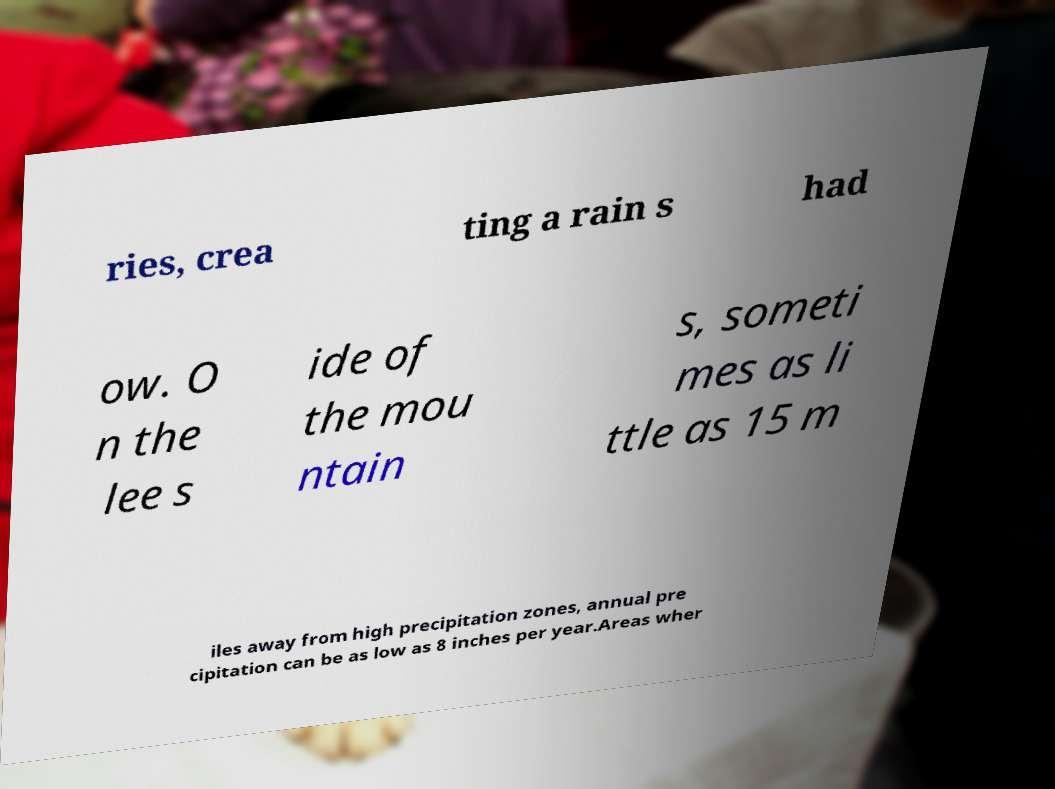There's text embedded in this image that I need extracted. Can you transcribe it verbatim? ries, crea ting a rain s had ow. O n the lee s ide of the mou ntain s, someti mes as li ttle as 15 m iles away from high precipitation zones, annual pre cipitation can be as low as 8 inches per year.Areas wher 